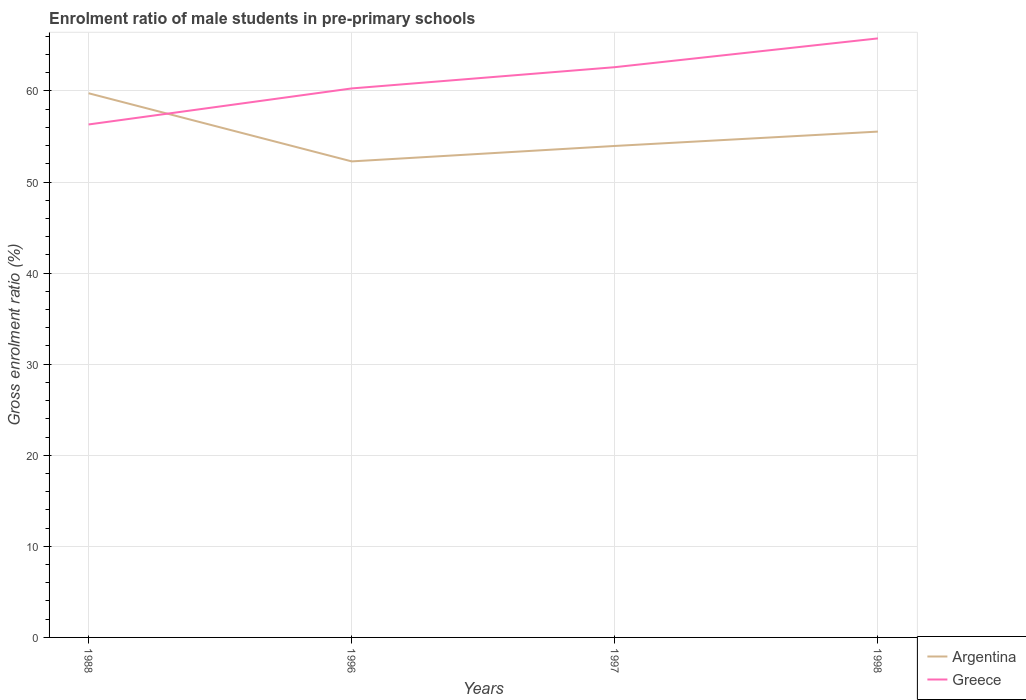Does the line corresponding to Argentina intersect with the line corresponding to Greece?
Your answer should be very brief. Yes. Is the number of lines equal to the number of legend labels?
Ensure brevity in your answer.  Yes. Across all years, what is the maximum enrolment ratio of male students in pre-primary schools in Argentina?
Offer a terse response. 52.26. What is the total enrolment ratio of male students in pre-primary schools in Argentina in the graph?
Provide a short and direct response. 4.21. What is the difference between the highest and the second highest enrolment ratio of male students in pre-primary schools in Greece?
Provide a succinct answer. 9.45. Is the enrolment ratio of male students in pre-primary schools in Argentina strictly greater than the enrolment ratio of male students in pre-primary schools in Greece over the years?
Your answer should be compact. No. How many lines are there?
Offer a terse response. 2. How many years are there in the graph?
Your answer should be very brief. 4. What is the difference between two consecutive major ticks on the Y-axis?
Ensure brevity in your answer.  10. Are the values on the major ticks of Y-axis written in scientific E-notation?
Keep it short and to the point. No. Does the graph contain grids?
Your response must be concise. Yes. What is the title of the graph?
Your answer should be compact. Enrolment ratio of male students in pre-primary schools. What is the label or title of the X-axis?
Ensure brevity in your answer.  Years. What is the label or title of the Y-axis?
Provide a short and direct response. Gross enrolment ratio (%). What is the Gross enrolment ratio (%) of Argentina in 1988?
Provide a succinct answer. 59.75. What is the Gross enrolment ratio (%) of Greece in 1988?
Provide a succinct answer. 56.32. What is the Gross enrolment ratio (%) of Argentina in 1996?
Your answer should be compact. 52.26. What is the Gross enrolment ratio (%) of Greece in 1996?
Ensure brevity in your answer.  60.27. What is the Gross enrolment ratio (%) in Argentina in 1997?
Provide a succinct answer. 53.96. What is the Gross enrolment ratio (%) of Greece in 1997?
Make the answer very short. 62.61. What is the Gross enrolment ratio (%) in Argentina in 1998?
Offer a very short reply. 55.53. What is the Gross enrolment ratio (%) in Greece in 1998?
Ensure brevity in your answer.  65.77. Across all years, what is the maximum Gross enrolment ratio (%) in Argentina?
Your answer should be compact. 59.75. Across all years, what is the maximum Gross enrolment ratio (%) of Greece?
Your answer should be compact. 65.77. Across all years, what is the minimum Gross enrolment ratio (%) of Argentina?
Make the answer very short. 52.26. Across all years, what is the minimum Gross enrolment ratio (%) of Greece?
Offer a terse response. 56.32. What is the total Gross enrolment ratio (%) in Argentina in the graph?
Provide a short and direct response. 221.5. What is the total Gross enrolment ratio (%) of Greece in the graph?
Your answer should be compact. 244.97. What is the difference between the Gross enrolment ratio (%) of Argentina in 1988 and that in 1996?
Provide a succinct answer. 7.48. What is the difference between the Gross enrolment ratio (%) of Greece in 1988 and that in 1996?
Offer a terse response. -3.96. What is the difference between the Gross enrolment ratio (%) in Argentina in 1988 and that in 1997?
Provide a short and direct response. 5.79. What is the difference between the Gross enrolment ratio (%) in Greece in 1988 and that in 1997?
Make the answer very short. -6.29. What is the difference between the Gross enrolment ratio (%) in Argentina in 1988 and that in 1998?
Offer a very short reply. 4.21. What is the difference between the Gross enrolment ratio (%) of Greece in 1988 and that in 1998?
Offer a very short reply. -9.45. What is the difference between the Gross enrolment ratio (%) of Argentina in 1996 and that in 1997?
Provide a short and direct response. -1.7. What is the difference between the Gross enrolment ratio (%) of Greece in 1996 and that in 1997?
Make the answer very short. -2.33. What is the difference between the Gross enrolment ratio (%) in Argentina in 1996 and that in 1998?
Your response must be concise. -3.27. What is the difference between the Gross enrolment ratio (%) in Greece in 1996 and that in 1998?
Keep it short and to the point. -5.49. What is the difference between the Gross enrolment ratio (%) in Argentina in 1997 and that in 1998?
Provide a short and direct response. -1.58. What is the difference between the Gross enrolment ratio (%) in Greece in 1997 and that in 1998?
Your answer should be very brief. -3.16. What is the difference between the Gross enrolment ratio (%) in Argentina in 1988 and the Gross enrolment ratio (%) in Greece in 1996?
Make the answer very short. -0.53. What is the difference between the Gross enrolment ratio (%) of Argentina in 1988 and the Gross enrolment ratio (%) of Greece in 1997?
Ensure brevity in your answer.  -2.86. What is the difference between the Gross enrolment ratio (%) in Argentina in 1988 and the Gross enrolment ratio (%) in Greece in 1998?
Give a very brief answer. -6.02. What is the difference between the Gross enrolment ratio (%) in Argentina in 1996 and the Gross enrolment ratio (%) in Greece in 1997?
Your response must be concise. -10.34. What is the difference between the Gross enrolment ratio (%) of Argentina in 1996 and the Gross enrolment ratio (%) of Greece in 1998?
Make the answer very short. -13.5. What is the difference between the Gross enrolment ratio (%) of Argentina in 1997 and the Gross enrolment ratio (%) of Greece in 1998?
Your response must be concise. -11.81. What is the average Gross enrolment ratio (%) of Argentina per year?
Offer a terse response. 55.38. What is the average Gross enrolment ratio (%) in Greece per year?
Make the answer very short. 61.24. In the year 1988, what is the difference between the Gross enrolment ratio (%) in Argentina and Gross enrolment ratio (%) in Greece?
Offer a terse response. 3.43. In the year 1996, what is the difference between the Gross enrolment ratio (%) of Argentina and Gross enrolment ratio (%) of Greece?
Offer a terse response. -8.01. In the year 1997, what is the difference between the Gross enrolment ratio (%) of Argentina and Gross enrolment ratio (%) of Greece?
Offer a very short reply. -8.65. In the year 1998, what is the difference between the Gross enrolment ratio (%) of Argentina and Gross enrolment ratio (%) of Greece?
Give a very brief answer. -10.23. What is the ratio of the Gross enrolment ratio (%) in Argentina in 1988 to that in 1996?
Your response must be concise. 1.14. What is the ratio of the Gross enrolment ratio (%) in Greece in 1988 to that in 1996?
Ensure brevity in your answer.  0.93. What is the ratio of the Gross enrolment ratio (%) in Argentina in 1988 to that in 1997?
Provide a succinct answer. 1.11. What is the ratio of the Gross enrolment ratio (%) in Greece in 1988 to that in 1997?
Offer a very short reply. 0.9. What is the ratio of the Gross enrolment ratio (%) of Argentina in 1988 to that in 1998?
Give a very brief answer. 1.08. What is the ratio of the Gross enrolment ratio (%) in Greece in 1988 to that in 1998?
Offer a terse response. 0.86. What is the ratio of the Gross enrolment ratio (%) in Argentina in 1996 to that in 1997?
Provide a short and direct response. 0.97. What is the ratio of the Gross enrolment ratio (%) of Greece in 1996 to that in 1997?
Your answer should be compact. 0.96. What is the ratio of the Gross enrolment ratio (%) of Argentina in 1996 to that in 1998?
Your answer should be very brief. 0.94. What is the ratio of the Gross enrolment ratio (%) of Greece in 1996 to that in 1998?
Your answer should be very brief. 0.92. What is the ratio of the Gross enrolment ratio (%) in Argentina in 1997 to that in 1998?
Offer a very short reply. 0.97. What is the difference between the highest and the second highest Gross enrolment ratio (%) in Argentina?
Provide a short and direct response. 4.21. What is the difference between the highest and the second highest Gross enrolment ratio (%) in Greece?
Provide a short and direct response. 3.16. What is the difference between the highest and the lowest Gross enrolment ratio (%) in Argentina?
Make the answer very short. 7.48. What is the difference between the highest and the lowest Gross enrolment ratio (%) of Greece?
Provide a succinct answer. 9.45. 